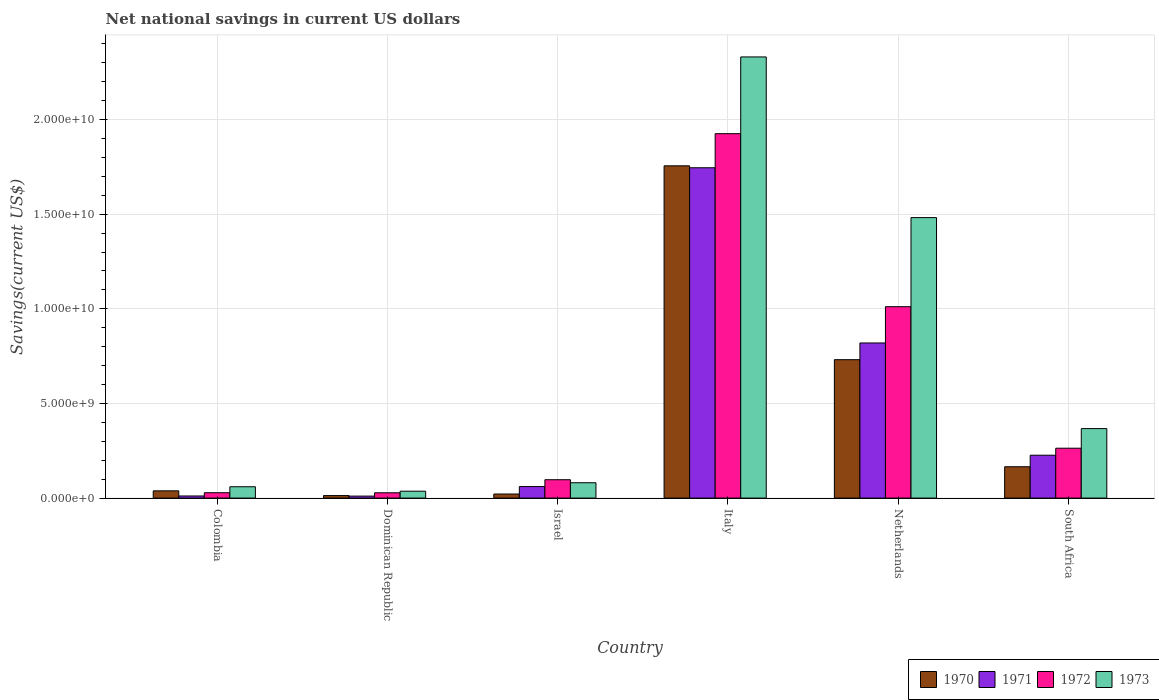How many groups of bars are there?
Ensure brevity in your answer.  6. Are the number of bars per tick equal to the number of legend labels?
Make the answer very short. Yes. Are the number of bars on each tick of the X-axis equal?
Keep it short and to the point. Yes. What is the label of the 2nd group of bars from the left?
Give a very brief answer. Dominican Republic. What is the net national savings in 1971 in Italy?
Your answer should be very brief. 1.75e+1. Across all countries, what is the maximum net national savings in 1973?
Offer a terse response. 2.33e+1. Across all countries, what is the minimum net national savings in 1970?
Your response must be concise. 1.33e+08. In which country was the net national savings in 1971 minimum?
Give a very brief answer. Dominican Republic. What is the total net national savings in 1972 in the graph?
Your answer should be very brief. 3.35e+1. What is the difference between the net national savings in 1971 in Dominican Republic and that in Israel?
Offer a terse response. -5.03e+08. What is the difference between the net national savings in 1973 in Israel and the net national savings in 1972 in Dominican Republic?
Provide a succinct answer. 5.30e+08. What is the average net national savings in 1972 per country?
Make the answer very short. 5.59e+09. What is the difference between the net national savings of/in 1973 and net national savings of/in 1971 in Netherlands?
Make the answer very short. 6.62e+09. In how many countries, is the net national savings in 1973 greater than 10000000000 US$?
Give a very brief answer. 2. What is the ratio of the net national savings in 1971 in Dominican Republic to that in Italy?
Provide a succinct answer. 0.01. Is the net national savings in 1972 in Italy less than that in Netherlands?
Your answer should be compact. No. Is the difference between the net national savings in 1973 in Colombia and Israel greater than the difference between the net national savings in 1971 in Colombia and Israel?
Offer a very short reply. Yes. What is the difference between the highest and the second highest net national savings in 1973?
Provide a short and direct response. -8.49e+09. What is the difference between the highest and the lowest net national savings in 1972?
Keep it short and to the point. 1.90e+1. What does the 3rd bar from the left in South Africa represents?
Your answer should be very brief. 1972. What does the 4th bar from the right in Israel represents?
Ensure brevity in your answer.  1970. Is it the case that in every country, the sum of the net national savings in 1972 and net national savings in 1973 is greater than the net national savings in 1971?
Provide a succinct answer. Yes. How many bars are there?
Provide a short and direct response. 24. Are all the bars in the graph horizontal?
Offer a very short reply. No. How many countries are there in the graph?
Your answer should be very brief. 6. Where does the legend appear in the graph?
Offer a terse response. Bottom right. How are the legend labels stacked?
Your response must be concise. Horizontal. What is the title of the graph?
Your answer should be compact. Net national savings in current US dollars. What is the label or title of the X-axis?
Provide a succinct answer. Country. What is the label or title of the Y-axis?
Make the answer very short. Savings(current US$). What is the Savings(current US$) of 1970 in Colombia?
Ensure brevity in your answer.  3.83e+08. What is the Savings(current US$) in 1971 in Colombia?
Offer a terse response. 1.11e+08. What is the Savings(current US$) in 1972 in Colombia?
Your answer should be compact. 2.84e+08. What is the Savings(current US$) in 1973 in Colombia?
Make the answer very short. 5.98e+08. What is the Savings(current US$) of 1970 in Dominican Republic?
Make the answer very short. 1.33e+08. What is the Savings(current US$) of 1971 in Dominican Republic?
Your response must be concise. 1.05e+08. What is the Savings(current US$) of 1972 in Dominican Republic?
Provide a succinct answer. 2.80e+08. What is the Savings(current US$) of 1973 in Dominican Republic?
Give a very brief answer. 3.65e+08. What is the Savings(current US$) in 1970 in Israel?
Offer a terse response. 2.15e+08. What is the Savings(current US$) in 1971 in Israel?
Ensure brevity in your answer.  6.09e+08. What is the Savings(current US$) in 1972 in Israel?
Offer a terse response. 9.71e+08. What is the Savings(current US$) in 1973 in Israel?
Make the answer very short. 8.11e+08. What is the Savings(current US$) in 1970 in Italy?
Make the answer very short. 1.76e+1. What is the Savings(current US$) in 1971 in Italy?
Your response must be concise. 1.75e+1. What is the Savings(current US$) of 1972 in Italy?
Offer a very short reply. 1.93e+1. What is the Savings(current US$) in 1973 in Italy?
Your answer should be very brief. 2.33e+1. What is the Savings(current US$) in 1970 in Netherlands?
Give a very brief answer. 7.31e+09. What is the Savings(current US$) of 1971 in Netherlands?
Your response must be concise. 8.20e+09. What is the Savings(current US$) of 1972 in Netherlands?
Give a very brief answer. 1.01e+1. What is the Savings(current US$) of 1973 in Netherlands?
Your response must be concise. 1.48e+1. What is the Savings(current US$) of 1970 in South Africa?
Provide a short and direct response. 1.66e+09. What is the Savings(current US$) of 1971 in South Africa?
Your answer should be very brief. 2.27e+09. What is the Savings(current US$) of 1972 in South Africa?
Offer a very short reply. 2.64e+09. What is the Savings(current US$) in 1973 in South Africa?
Offer a very short reply. 3.67e+09. Across all countries, what is the maximum Savings(current US$) of 1970?
Give a very brief answer. 1.76e+1. Across all countries, what is the maximum Savings(current US$) in 1971?
Ensure brevity in your answer.  1.75e+1. Across all countries, what is the maximum Savings(current US$) in 1972?
Provide a short and direct response. 1.93e+1. Across all countries, what is the maximum Savings(current US$) in 1973?
Offer a terse response. 2.33e+1. Across all countries, what is the minimum Savings(current US$) of 1970?
Your response must be concise. 1.33e+08. Across all countries, what is the minimum Savings(current US$) in 1971?
Provide a succinct answer. 1.05e+08. Across all countries, what is the minimum Savings(current US$) in 1972?
Your response must be concise. 2.80e+08. Across all countries, what is the minimum Savings(current US$) in 1973?
Offer a very short reply. 3.65e+08. What is the total Savings(current US$) of 1970 in the graph?
Provide a succinct answer. 2.73e+1. What is the total Savings(current US$) in 1971 in the graph?
Give a very brief answer. 2.87e+1. What is the total Savings(current US$) of 1972 in the graph?
Give a very brief answer. 3.35e+1. What is the total Savings(current US$) of 1973 in the graph?
Keep it short and to the point. 4.36e+1. What is the difference between the Savings(current US$) in 1970 in Colombia and that in Dominican Republic?
Offer a very short reply. 2.50e+08. What is the difference between the Savings(current US$) of 1971 in Colombia and that in Dominican Republic?
Offer a terse response. 6.03e+06. What is the difference between the Savings(current US$) of 1972 in Colombia and that in Dominican Republic?
Your answer should be compact. 3.48e+06. What is the difference between the Savings(current US$) in 1973 in Colombia and that in Dominican Republic?
Give a very brief answer. 2.34e+08. What is the difference between the Savings(current US$) of 1970 in Colombia and that in Israel?
Your answer should be compact. 1.68e+08. What is the difference between the Savings(current US$) of 1971 in Colombia and that in Israel?
Give a very brief answer. -4.97e+08. What is the difference between the Savings(current US$) in 1972 in Colombia and that in Israel?
Provide a succinct answer. -6.87e+08. What is the difference between the Savings(current US$) in 1973 in Colombia and that in Israel?
Keep it short and to the point. -2.12e+08. What is the difference between the Savings(current US$) in 1970 in Colombia and that in Italy?
Ensure brevity in your answer.  -1.72e+1. What is the difference between the Savings(current US$) in 1971 in Colombia and that in Italy?
Your answer should be compact. -1.73e+1. What is the difference between the Savings(current US$) of 1972 in Colombia and that in Italy?
Make the answer very short. -1.90e+1. What is the difference between the Savings(current US$) in 1973 in Colombia and that in Italy?
Offer a terse response. -2.27e+1. What is the difference between the Savings(current US$) of 1970 in Colombia and that in Netherlands?
Provide a short and direct response. -6.93e+09. What is the difference between the Savings(current US$) in 1971 in Colombia and that in Netherlands?
Keep it short and to the point. -8.08e+09. What is the difference between the Savings(current US$) of 1972 in Colombia and that in Netherlands?
Ensure brevity in your answer.  -9.83e+09. What is the difference between the Savings(current US$) in 1973 in Colombia and that in Netherlands?
Offer a terse response. -1.42e+1. What is the difference between the Savings(current US$) of 1970 in Colombia and that in South Africa?
Provide a short and direct response. -1.27e+09. What is the difference between the Savings(current US$) in 1971 in Colombia and that in South Africa?
Your answer should be compact. -2.15e+09. What is the difference between the Savings(current US$) of 1972 in Colombia and that in South Africa?
Offer a terse response. -2.35e+09. What is the difference between the Savings(current US$) of 1973 in Colombia and that in South Africa?
Ensure brevity in your answer.  -3.07e+09. What is the difference between the Savings(current US$) in 1970 in Dominican Republic and that in Israel?
Provide a succinct answer. -8.19e+07. What is the difference between the Savings(current US$) in 1971 in Dominican Republic and that in Israel?
Provide a succinct answer. -5.03e+08. What is the difference between the Savings(current US$) in 1972 in Dominican Republic and that in Israel?
Make the answer very short. -6.90e+08. What is the difference between the Savings(current US$) of 1973 in Dominican Republic and that in Israel?
Ensure brevity in your answer.  -4.46e+08. What is the difference between the Savings(current US$) of 1970 in Dominican Republic and that in Italy?
Make the answer very short. -1.74e+1. What is the difference between the Savings(current US$) in 1971 in Dominican Republic and that in Italy?
Offer a very short reply. -1.73e+1. What is the difference between the Savings(current US$) in 1972 in Dominican Republic and that in Italy?
Make the answer very short. -1.90e+1. What is the difference between the Savings(current US$) in 1973 in Dominican Republic and that in Italy?
Your response must be concise. -2.29e+1. What is the difference between the Savings(current US$) in 1970 in Dominican Republic and that in Netherlands?
Make the answer very short. -7.18e+09. What is the difference between the Savings(current US$) of 1971 in Dominican Republic and that in Netherlands?
Make the answer very short. -8.09e+09. What is the difference between the Savings(current US$) of 1972 in Dominican Republic and that in Netherlands?
Make the answer very short. -9.83e+09. What is the difference between the Savings(current US$) in 1973 in Dominican Republic and that in Netherlands?
Your response must be concise. -1.45e+1. What is the difference between the Savings(current US$) in 1970 in Dominican Republic and that in South Africa?
Provide a succinct answer. -1.52e+09. What is the difference between the Savings(current US$) in 1971 in Dominican Republic and that in South Africa?
Keep it short and to the point. -2.16e+09. What is the difference between the Savings(current US$) in 1972 in Dominican Republic and that in South Africa?
Make the answer very short. -2.35e+09. What is the difference between the Savings(current US$) in 1973 in Dominican Republic and that in South Africa?
Keep it short and to the point. -3.31e+09. What is the difference between the Savings(current US$) of 1970 in Israel and that in Italy?
Make the answer very short. -1.73e+1. What is the difference between the Savings(current US$) in 1971 in Israel and that in Italy?
Make the answer very short. -1.68e+1. What is the difference between the Savings(current US$) in 1972 in Israel and that in Italy?
Provide a succinct answer. -1.83e+1. What is the difference between the Savings(current US$) in 1973 in Israel and that in Italy?
Keep it short and to the point. -2.25e+1. What is the difference between the Savings(current US$) of 1970 in Israel and that in Netherlands?
Make the answer very short. -7.10e+09. What is the difference between the Savings(current US$) of 1971 in Israel and that in Netherlands?
Keep it short and to the point. -7.59e+09. What is the difference between the Savings(current US$) in 1972 in Israel and that in Netherlands?
Provide a short and direct response. -9.14e+09. What is the difference between the Savings(current US$) in 1973 in Israel and that in Netherlands?
Offer a very short reply. -1.40e+1. What is the difference between the Savings(current US$) of 1970 in Israel and that in South Africa?
Offer a very short reply. -1.44e+09. What is the difference between the Savings(current US$) of 1971 in Israel and that in South Africa?
Ensure brevity in your answer.  -1.66e+09. What is the difference between the Savings(current US$) in 1972 in Israel and that in South Africa?
Your response must be concise. -1.66e+09. What is the difference between the Savings(current US$) of 1973 in Israel and that in South Africa?
Provide a succinct answer. -2.86e+09. What is the difference between the Savings(current US$) in 1970 in Italy and that in Netherlands?
Provide a short and direct response. 1.02e+1. What is the difference between the Savings(current US$) of 1971 in Italy and that in Netherlands?
Keep it short and to the point. 9.26e+09. What is the difference between the Savings(current US$) in 1972 in Italy and that in Netherlands?
Your response must be concise. 9.14e+09. What is the difference between the Savings(current US$) in 1973 in Italy and that in Netherlands?
Make the answer very short. 8.49e+09. What is the difference between the Savings(current US$) in 1970 in Italy and that in South Africa?
Provide a short and direct response. 1.59e+1. What is the difference between the Savings(current US$) in 1971 in Italy and that in South Africa?
Ensure brevity in your answer.  1.52e+1. What is the difference between the Savings(current US$) of 1972 in Italy and that in South Africa?
Ensure brevity in your answer.  1.66e+1. What is the difference between the Savings(current US$) of 1973 in Italy and that in South Africa?
Offer a very short reply. 1.96e+1. What is the difference between the Savings(current US$) of 1970 in Netherlands and that in South Africa?
Make the answer very short. 5.66e+09. What is the difference between the Savings(current US$) of 1971 in Netherlands and that in South Africa?
Keep it short and to the point. 5.93e+09. What is the difference between the Savings(current US$) in 1972 in Netherlands and that in South Africa?
Your answer should be very brief. 7.48e+09. What is the difference between the Savings(current US$) of 1973 in Netherlands and that in South Africa?
Offer a very short reply. 1.11e+1. What is the difference between the Savings(current US$) in 1970 in Colombia and the Savings(current US$) in 1971 in Dominican Republic?
Give a very brief answer. 2.77e+08. What is the difference between the Savings(current US$) of 1970 in Colombia and the Savings(current US$) of 1972 in Dominican Republic?
Ensure brevity in your answer.  1.02e+08. What is the difference between the Savings(current US$) of 1970 in Colombia and the Savings(current US$) of 1973 in Dominican Republic?
Offer a terse response. 1.82e+07. What is the difference between the Savings(current US$) of 1971 in Colombia and the Savings(current US$) of 1972 in Dominican Republic?
Your answer should be very brief. -1.69e+08. What is the difference between the Savings(current US$) in 1971 in Colombia and the Savings(current US$) in 1973 in Dominican Republic?
Provide a short and direct response. -2.53e+08. What is the difference between the Savings(current US$) of 1972 in Colombia and the Savings(current US$) of 1973 in Dominican Republic?
Give a very brief answer. -8.05e+07. What is the difference between the Savings(current US$) of 1970 in Colombia and the Savings(current US$) of 1971 in Israel?
Ensure brevity in your answer.  -2.26e+08. What is the difference between the Savings(current US$) of 1970 in Colombia and the Savings(current US$) of 1972 in Israel?
Ensure brevity in your answer.  -5.88e+08. What is the difference between the Savings(current US$) in 1970 in Colombia and the Savings(current US$) in 1973 in Israel?
Offer a terse response. -4.28e+08. What is the difference between the Savings(current US$) of 1971 in Colombia and the Savings(current US$) of 1972 in Israel?
Offer a terse response. -8.59e+08. What is the difference between the Savings(current US$) in 1971 in Colombia and the Savings(current US$) in 1973 in Israel?
Offer a very short reply. -6.99e+08. What is the difference between the Savings(current US$) in 1972 in Colombia and the Savings(current US$) in 1973 in Israel?
Offer a terse response. -5.27e+08. What is the difference between the Savings(current US$) of 1970 in Colombia and the Savings(current US$) of 1971 in Italy?
Your answer should be compact. -1.71e+1. What is the difference between the Savings(current US$) in 1970 in Colombia and the Savings(current US$) in 1972 in Italy?
Offer a terse response. -1.89e+1. What is the difference between the Savings(current US$) in 1970 in Colombia and the Savings(current US$) in 1973 in Italy?
Offer a very short reply. -2.29e+1. What is the difference between the Savings(current US$) in 1971 in Colombia and the Savings(current US$) in 1972 in Italy?
Your response must be concise. -1.91e+1. What is the difference between the Savings(current US$) in 1971 in Colombia and the Savings(current US$) in 1973 in Italy?
Make the answer very short. -2.32e+1. What is the difference between the Savings(current US$) of 1972 in Colombia and the Savings(current US$) of 1973 in Italy?
Make the answer very short. -2.30e+1. What is the difference between the Savings(current US$) in 1970 in Colombia and the Savings(current US$) in 1971 in Netherlands?
Offer a terse response. -7.81e+09. What is the difference between the Savings(current US$) of 1970 in Colombia and the Savings(current US$) of 1972 in Netherlands?
Keep it short and to the point. -9.73e+09. What is the difference between the Savings(current US$) of 1970 in Colombia and the Savings(current US$) of 1973 in Netherlands?
Offer a very short reply. -1.44e+1. What is the difference between the Savings(current US$) of 1971 in Colombia and the Savings(current US$) of 1972 in Netherlands?
Your response must be concise. -1.00e+1. What is the difference between the Savings(current US$) of 1971 in Colombia and the Savings(current US$) of 1973 in Netherlands?
Your answer should be very brief. -1.47e+1. What is the difference between the Savings(current US$) of 1972 in Colombia and the Savings(current US$) of 1973 in Netherlands?
Ensure brevity in your answer.  -1.45e+1. What is the difference between the Savings(current US$) of 1970 in Colombia and the Savings(current US$) of 1971 in South Africa?
Your response must be concise. -1.88e+09. What is the difference between the Savings(current US$) in 1970 in Colombia and the Savings(current US$) in 1972 in South Africa?
Make the answer very short. -2.25e+09. What is the difference between the Savings(current US$) in 1970 in Colombia and the Savings(current US$) in 1973 in South Africa?
Your answer should be compact. -3.29e+09. What is the difference between the Savings(current US$) of 1971 in Colombia and the Savings(current US$) of 1972 in South Africa?
Your answer should be compact. -2.52e+09. What is the difference between the Savings(current US$) in 1971 in Colombia and the Savings(current US$) in 1973 in South Africa?
Your answer should be compact. -3.56e+09. What is the difference between the Savings(current US$) in 1972 in Colombia and the Savings(current US$) in 1973 in South Africa?
Provide a succinct answer. -3.39e+09. What is the difference between the Savings(current US$) of 1970 in Dominican Republic and the Savings(current US$) of 1971 in Israel?
Give a very brief answer. -4.76e+08. What is the difference between the Savings(current US$) of 1970 in Dominican Republic and the Savings(current US$) of 1972 in Israel?
Provide a short and direct response. -8.38e+08. What is the difference between the Savings(current US$) in 1970 in Dominican Republic and the Savings(current US$) in 1973 in Israel?
Keep it short and to the point. -6.78e+08. What is the difference between the Savings(current US$) in 1971 in Dominican Republic and the Savings(current US$) in 1972 in Israel?
Offer a very short reply. -8.65e+08. What is the difference between the Savings(current US$) in 1971 in Dominican Republic and the Savings(current US$) in 1973 in Israel?
Keep it short and to the point. -7.05e+08. What is the difference between the Savings(current US$) of 1972 in Dominican Republic and the Savings(current US$) of 1973 in Israel?
Your answer should be compact. -5.30e+08. What is the difference between the Savings(current US$) in 1970 in Dominican Republic and the Savings(current US$) in 1971 in Italy?
Your answer should be compact. -1.73e+1. What is the difference between the Savings(current US$) of 1970 in Dominican Republic and the Savings(current US$) of 1972 in Italy?
Provide a short and direct response. -1.91e+1. What is the difference between the Savings(current US$) of 1970 in Dominican Republic and the Savings(current US$) of 1973 in Italy?
Your response must be concise. -2.32e+1. What is the difference between the Savings(current US$) of 1971 in Dominican Republic and the Savings(current US$) of 1972 in Italy?
Provide a short and direct response. -1.91e+1. What is the difference between the Savings(current US$) in 1971 in Dominican Republic and the Savings(current US$) in 1973 in Italy?
Make the answer very short. -2.32e+1. What is the difference between the Savings(current US$) in 1972 in Dominican Republic and the Savings(current US$) in 1973 in Italy?
Offer a very short reply. -2.30e+1. What is the difference between the Savings(current US$) of 1970 in Dominican Republic and the Savings(current US$) of 1971 in Netherlands?
Your response must be concise. -8.06e+09. What is the difference between the Savings(current US$) in 1970 in Dominican Republic and the Savings(current US$) in 1972 in Netherlands?
Offer a very short reply. -9.98e+09. What is the difference between the Savings(current US$) of 1970 in Dominican Republic and the Savings(current US$) of 1973 in Netherlands?
Your response must be concise. -1.47e+1. What is the difference between the Savings(current US$) of 1971 in Dominican Republic and the Savings(current US$) of 1972 in Netherlands?
Keep it short and to the point. -1.00e+1. What is the difference between the Savings(current US$) of 1971 in Dominican Republic and the Savings(current US$) of 1973 in Netherlands?
Offer a terse response. -1.47e+1. What is the difference between the Savings(current US$) in 1972 in Dominican Republic and the Savings(current US$) in 1973 in Netherlands?
Your answer should be compact. -1.45e+1. What is the difference between the Savings(current US$) of 1970 in Dominican Republic and the Savings(current US$) of 1971 in South Africa?
Offer a terse response. -2.13e+09. What is the difference between the Savings(current US$) in 1970 in Dominican Republic and the Savings(current US$) in 1972 in South Africa?
Offer a terse response. -2.50e+09. What is the difference between the Savings(current US$) in 1970 in Dominican Republic and the Savings(current US$) in 1973 in South Africa?
Offer a terse response. -3.54e+09. What is the difference between the Savings(current US$) in 1971 in Dominican Republic and the Savings(current US$) in 1972 in South Africa?
Offer a terse response. -2.53e+09. What is the difference between the Savings(current US$) of 1971 in Dominican Republic and the Savings(current US$) of 1973 in South Africa?
Offer a very short reply. -3.57e+09. What is the difference between the Savings(current US$) of 1972 in Dominican Republic and the Savings(current US$) of 1973 in South Africa?
Your answer should be compact. -3.39e+09. What is the difference between the Savings(current US$) of 1970 in Israel and the Savings(current US$) of 1971 in Italy?
Your response must be concise. -1.72e+1. What is the difference between the Savings(current US$) of 1970 in Israel and the Savings(current US$) of 1972 in Italy?
Make the answer very short. -1.90e+1. What is the difference between the Savings(current US$) of 1970 in Israel and the Savings(current US$) of 1973 in Italy?
Your answer should be very brief. -2.31e+1. What is the difference between the Savings(current US$) in 1971 in Israel and the Savings(current US$) in 1972 in Italy?
Keep it short and to the point. -1.86e+1. What is the difference between the Savings(current US$) of 1971 in Israel and the Savings(current US$) of 1973 in Italy?
Make the answer very short. -2.27e+1. What is the difference between the Savings(current US$) in 1972 in Israel and the Savings(current US$) in 1973 in Italy?
Keep it short and to the point. -2.23e+1. What is the difference between the Savings(current US$) of 1970 in Israel and the Savings(current US$) of 1971 in Netherlands?
Give a very brief answer. -7.98e+09. What is the difference between the Savings(current US$) of 1970 in Israel and the Savings(current US$) of 1972 in Netherlands?
Offer a very short reply. -9.90e+09. What is the difference between the Savings(current US$) of 1970 in Israel and the Savings(current US$) of 1973 in Netherlands?
Keep it short and to the point. -1.46e+1. What is the difference between the Savings(current US$) in 1971 in Israel and the Savings(current US$) in 1972 in Netherlands?
Keep it short and to the point. -9.50e+09. What is the difference between the Savings(current US$) in 1971 in Israel and the Savings(current US$) in 1973 in Netherlands?
Provide a short and direct response. -1.42e+1. What is the difference between the Savings(current US$) of 1972 in Israel and the Savings(current US$) of 1973 in Netherlands?
Your response must be concise. -1.38e+1. What is the difference between the Savings(current US$) in 1970 in Israel and the Savings(current US$) in 1971 in South Africa?
Make the answer very short. -2.05e+09. What is the difference between the Savings(current US$) in 1970 in Israel and the Savings(current US$) in 1972 in South Africa?
Keep it short and to the point. -2.42e+09. What is the difference between the Savings(current US$) in 1970 in Israel and the Savings(current US$) in 1973 in South Africa?
Your answer should be compact. -3.46e+09. What is the difference between the Savings(current US$) in 1971 in Israel and the Savings(current US$) in 1972 in South Africa?
Provide a short and direct response. -2.03e+09. What is the difference between the Savings(current US$) of 1971 in Israel and the Savings(current US$) of 1973 in South Africa?
Give a very brief answer. -3.06e+09. What is the difference between the Savings(current US$) in 1972 in Israel and the Savings(current US$) in 1973 in South Africa?
Ensure brevity in your answer.  -2.70e+09. What is the difference between the Savings(current US$) of 1970 in Italy and the Savings(current US$) of 1971 in Netherlands?
Offer a very short reply. 9.36e+09. What is the difference between the Savings(current US$) in 1970 in Italy and the Savings(current US$) in 1972 in Netherlands?
Give a very brief answer. 7.44e+09. What is the difference between the Savings(current US$) of 1970 in Italy and the Savings(current US$) of 1973 in Netherlands?
Provide a short and direct response. 2.74e+09. What is the difference between the Savings(current US$) in 1971 in Italy and the Savings(current US$) in 1972 in Netherlands?
Your answer should be very brief. 7.34e+09. What is the difference between the Savings(current US$) of 1971 in Italy and the Savings(current US$) of 1973 in Netherlands?
Give a very brief answer. 2.63e+09. What is the difference between the Savings(current US$) of 1972 in Italy and the Savings(current US$) of 1973 in Netherlands?
Offer a very short reply. 4.44e+09. What is the difference between the Savings(current US$) in 1970 in Italy and the Savings(current US$) in 1971 in South Africa?
Your response must be concise. 1.53e+1. What is the difference between the Savings(current US$) in 1970 in Italy and the Savings(current US$) in 1972 in South Africa?
Give a very brief answer. 1.49e+1. What is the difference between the Savings(current US$) of 1970 in Italy and the Savings(current US$) of 1973 in South Africa?
Your answer should be very brief. 1.39e+1. What is the difference between the Savings(current US$) in 1971 in Italy and the Savings(current US$) in 1972 in South Africa?
Your answer should be very brief. 1.48e+1. What is the difference between the Savings(current US$) in 1971 in Italy and the Savings(current US$) in 1973 in South Africa?
Offer a terse response. 1.38e+1. What is the difference between the Savings(current US$) in 1972 in Italy and the Savings(current US$) in 1973 in South Africa?
Your answer should be very brief. 1.56e+1. What is the difference between the Savings(current US$) in 1970 in Netherlands and the Savings(current US$) in 1971 in South Africa?
Your response must be concise. 5.05e+09. What is the difference between the Savings(current US$) of 1970 in Netherlands and the Savings(current US$) of 1972 in South Africa?
Provide a succinct answer. 4.68e+09. What is the difference between the Savings(current US$) of 1970 in Netherlands and the Savings(current US$) of 1973 in South Africa?
Provide a short and direct response. 3.64e+09. What is the difference between the Savings(current US$) of 1971 in Netherlands and the Savings(current US$) of 1972 in South Africa?
Offer a terse response. 5.56e+09. What is the difference between the Savings(current US$) of 1971 in Netherlands and the Savings(current US$) of 1973 in South Africa?
Make the answer very short. 4.52e+09. What is the difference between the Savings(current US$) in 1972 in Netherlands and the Savings(current US$) in 1973 in South Africa?
Ensure brevity in your answer.  6.44e+09. What is the average Savings(current US$) in 1970 per country?
Provide a short and direct response. 4.54e+09. What is the average Savings(current US$) in 1971 per country?
Offer a very short reply. 4.79e+09. What is the average Savings(current US$) in 1972 per country?
Provide a short and direct response. 5.59e+09. What is the average Savings(current US$) in 1973 per country?
Offer a very short reply. 7.26e+09. What is the difference between the Savings(current US$) of 1970 and Savings(current US$) of 1971 in Colombia?
Give a very brief answer. 2.71e+08. What is the difference between the Savings(current US$) in 1970 and Savings(current US$) in 1972 in Colombia?
Offer a very short reply. 9.87e+07. What is the difference between the Savings(current US$) of 1970 and Savings(current US$) of 1973 in Colombia?
Ensure brevity in your answer.  -2.16e+08. What is the difference between the Savings(current US$) in 1971 and Savings(current US$) in 1972 in Colombia?
Provide a succinct answer. -1.73e+08. What is the difference between the Savings(current US$) in 1971 and Savings(current US$) in 1973 in Colombia?
Keep it short and to the point. -4.87e+08. What is the difference between the Savings(current US$) in 1972 and Savings(current US$) in 1973 in Colombia?
Provide a succinct answer. -3.14e+08. What is the difference between the Savings(current US$) of 1970 and Savings(current US$) of 1971 in Dominican Republic?
Make the answer very short. 2.74e+07. What is the difference between the Savings(current US$) of 1970 and Savings(current US$) of 1972 in Dominican Republic?
Provide a succinct answer. -1.48e+08. What is the difference between the Savings(current US$) in 1970 and Savings(current US$) in 1973 in Dominican Republic?
Provide a succinct answer. -2.32e+08. What is the difference between the Savings(current US$) in 1971 and Savings(current US$) in 1972 in Dominican Republic?
Give a very brief answer. -1.75e+08. What is the difference between the Savings(current US$) in 1971 and Savings(current US$) in 1973 in Dominican Republic?
Provide a succinct answer. -2.59e+08. What is the difference between the Savings(current US$) in 1972 and Savings(current US$) in 1973 in Dominican Republic?
Keep it short and to the point. -8.40e+07. What is the difference between the Savings(current US$) in 1970 and Savings(current US$) in 1971 in Israel?
Provide a succinct answer. -3.94e+08. What is the difference between the Savings(current US$) of 1970 and Savings(current US$) of 1972 in Israel?
Offer a very short reply. -7.56e+08. What is the difference between the Savings(current US$) in 1970 and Savings(current US$) in 1973 in Israel?
Provide a succinct answer. -5.96e+08. What is the difference between the Savings(current US$) of 1971 and Savings(current US$) of 1972 in Israel?
Your answer should be compact. -3.62e+08. What is the difference between the Savings(current US$) in 1971 and Savings(current US$) in 1973 in Israel?
Provide a short and direct response. -2.02e+08. What is the difference between the Savings(current US$) in 1972 and Savings(current US$) in 1973 in Israel?
Your response must be concise. 1.60e+08. What is the difference between the Savings(current US$) of 1970 and Savings(current US$) of 1971 in Italy?
Your response must be concise. 1.03e+08. What is the difference between the Savings(current US$) of 1970 and Savings(current US$) of 1972 in Italy?
Offer a terse response. -1.70e+09. What is the difference between the Savings(current US$) in 1970 and Savings(current US$) in 1973 in Italy?
Your answer should be compact. -5.75e+09. What is the difference between the Savings(current US$) in 1971 and Savings(current US$) in 1972 in Italy?
Keep it short and to the point. -1.80e+09. What is the difference between the Savings(current US$) in 1971 and Savings(current US$) in 1973 in Italy?
Your response must be concise. -5.86e+09. What is the difference between the Savings(current US$) of 1972 and Savings(current US$) of 1973 in Italy?
Offer a very short reply. -4.05e+09. What is the difference between the Savings(current US$) in 1970 and Savings(current US$) in 1971 in Netherlands?
Keep it short and to the point. -8.83e+08. What is the difference between the Savings(current US$) of 1970 and Savings(current US$) of 1972 in Netherlands?
Provide a short and direct response. -2.80e+09. What is the difference between the Savings(current US$) in 1970 and Savings(current US$) in 1973 in Netherlands?
Give a very brief answer. -7.51e+09. What is the difference between the Savings(current US$) of 1971 and Savings(current US$) of 1972 in Netherlands?
Your answer should be very brief. -1.92e+09. What is the difference between the Savings(current US$) in 1971 and Savings(current US$) in 1973 in Netherlands?
Make the answer very short. -6.62e+09. What is the difference between the Savings(current US$) in 1972 and Savings(current US$) in 1973 in Netherlands?
Your answer should be very brief. -4.71e+09. What is the difference between the Savings(current US$) in 1970 and Savings(current US$) in 1971 in South Africa?
Provide a short and direct response. -6.09e+08. What is the difference between the Savings(current US$) of 1970 and Savings(current US$) of 1972 in South Africa?
Your answer should be compact. -9.79e+08. What is the difference between the Savings(current US$) of 1970 and Savings(current US$) of 1973 in South Africa?
Keep it short and to the point. -2.02e+09. What is the difference between the Savings(current US$) in 1971 and Savings(current US$) in 1972 in South Africa?
Offer a terse response. -3.70e+08. What is the difference between the Savings(current US$) of 1971 and Savings(current US$) of 1973 in South Africa?
Offer a very short reply. -1.41e+09. What is the difference between the Savings(current US$) in 1972 and Savings(current US$) in 1973 in South Africa?
Keep it short and to the point. -1.04e+09. What is the ratio of the Savings(current US$) in 1970 in Colombia to that in Dominican Republic?
Keep it short and to the point. 2.88. What is the ratio of the Savings(current US$) of 1971 in Colombia to that in Dominican Republic?
Offer a terse response. 1.06. What is the ratio of the Savings(current US$) of 1972 in Colombia to that in Dominican Republic?
Your answer should be very brief. 1.01. What is the ratio of the Savings(current US$) in 1973 in Colombia to that in Dominican Republic?
Give a very brief answer. 1.64. What is the ratio of the Savings(current US$) of 1970 in Colombia to that in Israel?
Your answer should be very brief. 1.78. What is the ratio of the Savings(current US$) in 1971 in Colombia to that in Israel?
Your answer should be very brief. 0.18. What is the ratio of the Savings(current US$) in 1972 in Colombia to that in Israel?
Your response must be concise. 0.29. What is the ratio of the Savings(current US$) in 1973 in Colombia to that in Israel?
Offer a very short reply. 0.74. What is the ratio of the Savings(current US$) in 1970 in Colombia to that in Italy?
Provide a succinct answer. 0.02. What is the ratio of the Savings(current US$) of 1971 in Colombia to that in Italy?
Your answer should be very brief. 0.01. What is the ratio of the Savings(current US$) of 1972 in Colombia to that in Italy?
Offer a very short reply. 0.01. What is the ratio of the Savings(current US$) in 1973 in Colombia to that in Italy?
Make the answer very short. 0.03. What is the ratio of the Savings(current US$) of 1970 in Colombia to that in Netherlands?
Offer a very short reply. 0.05. What is the ratio of the Savings(current US$) of 1971 in Colombia to that in Netherlands?
Keep it short and to the point. 0.01. What is the ratio of the Savings(current US$) of 1972 in Colombia to that in Netherlands?
Provide a short and direct response. 0.03. What is the ratio of the Savings(current US$) in 1973 in Colombia to that in Netherlands?
Your answer should be compact. 0.04. What is the ratio of the Savings(current US$) in 1970 in Colombia to that in South Africa?
Your answer should be compact. 0.23. What is the ratio of the Savings(current US$) in 1971 in Colombia to that in South Africa?
Your answer should be very brief. 0.05. What is the ratio of the Savings(current US$) of 1972 in Colombia to that in South Africa?
Make the answer very short. 0.11. What is the ratio of the Savings(current US$) in 1973 in Colombia to that in South Africa?
Give a very brief answer. 0.16. What is the ratio of the Savings(current US$) in 1970 in Dominican Republic to that in Israel?
Provide a short and direct response. 0.62. What is the ratio of the Savings(current US$) of 1971 in Dominican Republic to that in Israel?
Make the answer very short. 0.17. What is the ratio of the Savings(current US$) of 1972 in Dominican Republic to that in Israel?
Offer a terse response. 0.29. What is the ratio of the Savings(current US$) in 1973 in Dominican Republic to that in Israel?
Ensure brevity in your answer.  0.45. What is the ratio of the Savings(current US$) of 1970 in Dominican Republic to that in Italy?
Provide a succinct answer. 0.01. What is the ratio of the Savings(current US$) in 1971 in Dominican Republic to that in Italy?
Provide a succinct answer. 0.01. What is the ratio of the Savings(current US$) of 1972 in Dominican Republic to that in Italy?
Ensure brevity in your answer.  0.01. What is the ratio of the Savings(current US$) of 1973 in Dominican Republic to that in Italy?
Ensure brevity in your answer.  0.02. What is the ratio of the Savings(current US$) of 1970 in Dominican Republic to that in Netherlands?
Ensure brevity in your answer.  0.02. What is the ratio of the Savings(current US$) in 1971 in Dominican Republic to that in Netherlands?
Keep it short and to the point. 0.01. What is the ratio of the Savings(current US$) of 1972 in Dominican Republic to that in Netherlands?
Your answer should be very brief. 0.03. What is the ratio of the Savings(current US$) in 1973 in Dominican Republic to that in Netherlands?
Provide a short and direct response. 0.02. What is the ratio of the Savings(current US$) of 1970 in Dominican Republic to that in South Africa?
Provide a short and direct response. 0.08. What is the ratio of the Savings(current US$) in 1971 in Dominican Republic to that in South Africa?
Offer a terse response. 0.05. What is the ratio of the Savings(current US$) of 1972 in Dominican Republic to that in South Africa?
Ensure brevity in your answer.  0.11. What is the ratio of the Savings(current US$) in 1973 in Dominican Republic to that in South Africa?
Offer a terse response. 0.1. What is the ratio of the Savings(current US$) in 1970 in Israel to that in Italy?
Provide a succinct answer. 0.01. What is the ratio of the Savings(current US$) in 1971 in Israel to that in Italy?
Ensure brevity in your answer.  0.03. What is the ratio of the Savings(current US$) in 1972 in Israel to that in Italy?
Keep it short and to the point. 0.05. What is the ratio of the Savings(current US$) in 1973 in Israel to that in Italy?
Your answer should be compact. 0.03. What is the ratio of the Savings(current US$) of 1970 in Israel to that in Netherlands?
Your answer should be very brief. 0.03. What is the ratio of the Savings(current US$) of 1971 in Israel to that in Netherlands?
Give a very brief answer. 0.07. What is the ratio of the Savings(current US$) in 1972 in Israel to that in Netherlands?
Keep it short and to the point. 0.1. What is the ratio of the Savings(current US$) of 1973 in Israel to that in Netherlands?
Your answer should be very brief. 0.05. What is the ratio of the Savings(current US$) in 1970 in Israel to that in South Africa?
Your answer should be compact. 0.13. What is the ratio of the Savings(current US$) of 1971 in Israel to that in South Africa?
Your answer should be very brief. 0.27. What is the ratio of the Savings(current US$) of 1972 in Israel to that in South Africa?
Your answer should be compact. 0.37. What is the ratio of the Savings(current US$) in 1973 in Israel to that in South Africa?
Make the answer very short. 0.22. What is the ratio of the Savings(current US$) in 1970 in Italy to that in Netherlands?
Give a very brief answer. 2.4. What is the ratio of the Savings(current US$) of 1971 in Italy to that in Netherlands?
Offer a very short reply. 2.13. What is the ratio of the Savings(current US$) in 1972 in Italy to that in Netherlands?
Offer a terse response. 1.9. What is the ratio of the Savings(current US$) in 1973 in Italy to that in Netherlands?
Make the answer very short. 1.57. What is the ratio of the Savings(current US$) in 1970 in Italy to that in South Africa?
Your answer should be very brief. 10.6. What is the ratio of the Savings(current US$) in 1971 in Italy to that in South Africa?
Make the answer very short. 7.7. What is the ratio of the Savings(current US$) of 1972 in Italy to that in South Africa?
Give a very brief answer. 7.31. What is the ratio of the Savings(current US$) of 1973 in Italy to that in South Africa?
Make the answer very short. 6.35. What is the ratio of the Savings(current US$) in 1970 in Netherlands to that in South Africa?
Provide a short and direct response. 4.42. What is the ratio of the Savings(current US$) of 1971 in Netherlands to that in South Africa?
Offer a terse response. 3.62. What is the ratio of the Savings(current US$) in 1972 in Netherlands to that in South Africa?
Ensure brevity in your answer.  3.84. What is the ratio of the Savings(current US$) in 1973 in Netherlands to that in South Africa?
Offer a terse response. 4.04. What is the difference between the highest and the second highest Savings(current US$) in 1970?
Your answer should be compact. 1.02e+1. What is the difference between the highest and the second highest Savings(current US$) in 1971?
Offer a very short reply. 9.26e+09. What is the difference between the highest and the second highest Savings(current US$) of 1972?
Ensure brevity in your answer.  9.14e+09. What is the difference between the highest and the second highest Savings(current US$) in 1973?
Provide a short and direct response. 8.49e+09. What is the difference between the highest and the lowest Savings(current US$) in 1970?
Your response must be concise. 1.74e+1. What is the difference between the highest and the lowest Savings(current US$) in 1971?
Offer a very short reply. 1.73e+1. What is the difference between the highest and the lowest Savings(current US$) of 1972?
Your response must be concise. 1.90e+1. What is the difference between the highest and the lowest Savings(current US$) in 1973?
Offer a very short reply. 2.29e+1. 